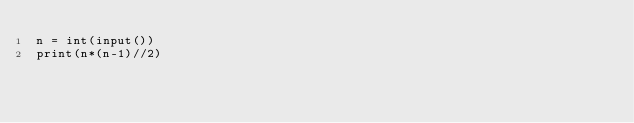<code> <loc_0><loc_0><loc_500><loc_500><_Python_>n = int(input())
print(n*(n-1)//2)</code> 